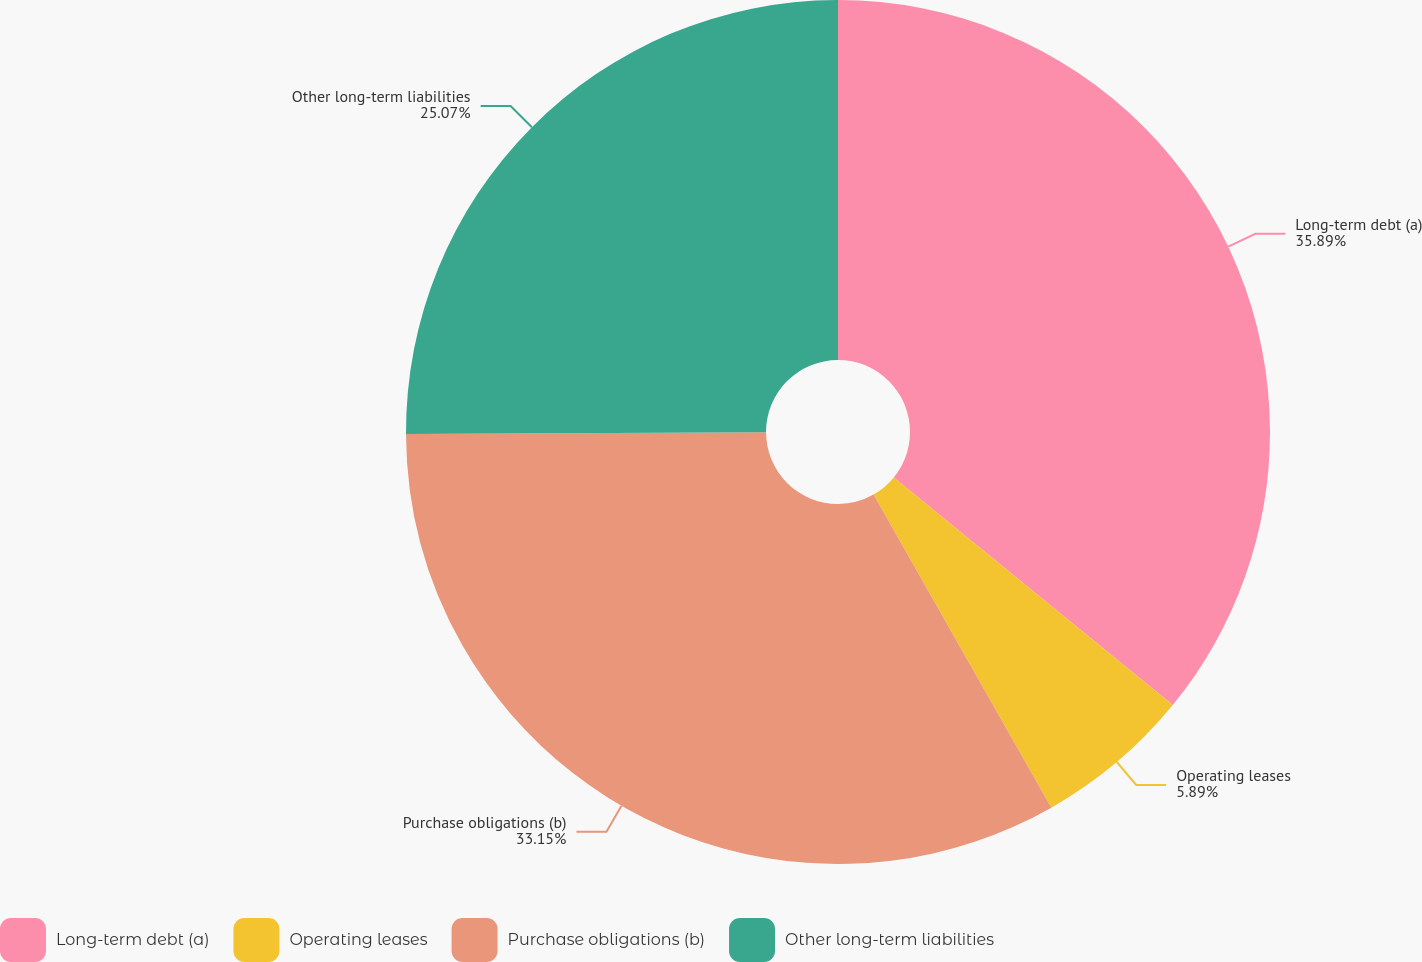Convert chart. <chart><loc_0><loc_0><loc_500><loc_500><pie_chart><fcel>Long-term debt (a)<fcel>Operating leases<fcel>Purchase obligations (b)<fcel>Other long-term liabilities<nl><fcel>35.89%<fcel>5.89%<fcel>33.15%<fcel>25.07%<nl></chart> 